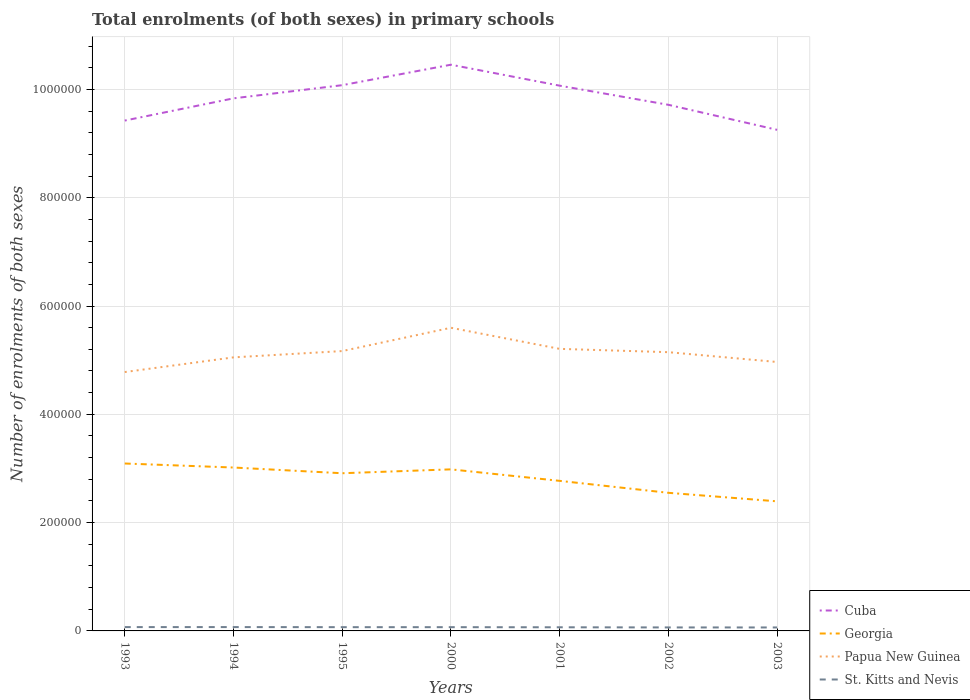How many different coloured lines are there?
Provide a short and direct response. 4. Is the number of lines equal to the number of legend labels?
Ensure brevity in your answer.  Yes. Across all years, what is the maximum number of enrolments in primary schools in Georgia?
Keep it short and to the point. 2.39e+05. What is the total number of enrolments in primary schools in St. Kitts and Nevis in the graph?
Give a very brief answer. 691. What is the difference between the highest and the second highest number of enrolments in primary schools in Papua New Guinea?
Provide a short and direct response. 8.18e+04. What is the difference between the highest and the lowest number of enrolments in primary schools in Papua New Guinea?
Make the answer very short. 4. Is the number of enrolments in primary schools in Papua New Guinea strictly greater than the number of enrolments in primary schools in Cuba over the years?
Offer a terse response. Yes. Are the values on the major ticks of Y-axis written in scientific E-notation?
Your answer should be very brief. No. Does the graph contain any zero values?
Make the answer very short. No. Does the graph contain grids?
Provide a short and direct response. Yes. Where does the legend appear in the graph?
Provide a short and direct response. Bottom right. How many legend labels are there?
Keep it short and to the point. 4. What is the title of the graph?
Provide a succinct answer. Total enrolments (of both sexes) in primary schools. Does "Solomon Islands" appear as one of the legend labels in the graph?
Ensure brevity in your answer.  No. What is the label or title of the X-axis?
Keep it short and to the point. Years. What is the label or title of the Y-axis?
Ensure brevity in your answer.  Number of enrolments of both sexes. What is the Number of enrolments of both sexes of Cuba in 1993?
Your response must be concise. 9.42e+05. What is the Number of enrolments of both sexes of Georgia in 1993?
Make the answer very short. 3.09e+05. What is the Number of enrolments of both sexes of Papua New Guinea in 1993?
Make the answer very short. 4.78e+05. What is the Number of enrolments of both sexes of St. Kitts and Nevis in 1993?
Keep it short and to the point. 7068. What is the Number of enrolments of both sexes in Cuba in 1994?
Provide a succinct answer. 9.83e+05. What is the Number of enrolments of both sexes of Georgia in 1994?
Provide a short and direct response. 3.02e+05. What is the Number of enrolments of both sexes in Papua New Guinea in 1994?
Your response must be concise. 5.05e+05. What is the Number of enrolments of both sexes in St. Kitts and Nevis in 1994?
Ensure brevity in your answer.  7092. What is the Number of enrolments of both sexes of Cuba in 1995?
Provide a short and direct response. 1.01e+06. What is the Number of enrolments of both sexes in Georgia in 1995?
Provide a succinct answer. 2.91e+05. What is the Number of enrolments of both sexes of Papua New Guinea in 1995?
Offer a very short reply. 5.17e+05. What is the Number of enrolments of both sexes in St. Kitts and Nevis in 1995?
Make the answer very short. 6938. What is the Number of enrolments of both sexes in Cuba in 2000?
Offer a terse response. 1.05e+06. What is the Number of enrolments of both sexes of Georgia in 2000?
Your answer should be very brief. 2.98e+05. What is the Number of enrolments of both sexes in Papua New Guinea in 2000?
Keep it short and to the point. 5.60e+05. What is the Number of enrolments of both sexes in St. Kitts and Nevis in 2000?
Offer a very short reply. 6922. What is the Number of enrolments of both sexes of Cuba in 2001?
Your response must be concise. 1.01e+06. What is the Number of enrolments of both sexes in Georgia in 2001?
Make the answer very short. 2.77e+05. What is the Number of enrolments of both sexes in Papua New Guinea in 2001?
Your answer should be compact. 5.21e+05. What is the Number of enrolments of both sexes in St. Kitts and Nevis in 2001?
Your answer should be compact. 6717. What is the Number of enrolments of both sexes in Cuba in 2002?
Your answer should be compact. 9.72e+05. What is the Number of enrolments of both sexes of Georgia in 2002?
Your answer should be compact. 2.55e+05. What is the Number of enrolments of both sexes of Papua New Guinea in 2002?
Your answer should be compact. 5.15e+05. What is the Number of enrolments of both sexes of St. Kitts and Nevis in 2002?
Provide a succinct answer. 6440. What is the Number of enrolments of both sexes in Cuba in 2003?
Make the answer very short. 9.25e+05. What is the Number of enrolments of both sexes of Georgia in 2003?
Offer a very short reply. 2.39e+05. What is the Number of enrolments of both sexes of Papua New Guinea in 2003?
Make the answer very short. 4.97e+05. What is the Number of enrolments of both sexes in St. Kitts and Nevis in 2003?
Your answer should be very brief. 6401. Across all years, what is the maximum Number of enrolments of both sexes in Cuba?
Your answer should be compact. 1.05e+06. Across all years, what is the maximum Number of enrolments of both sexes of Georgia?
Offer a very short reply. 3.09e+05. Across all years, what is the maximum Number of enrolments of both sexes of Papua New Guinea?
Provide a short and direct response. 5.60e+05. Across all years, what is the maximum Number of enrolments of both sexes in St. Kitts and Nevis?
Offer a very short reply. 7092. Across all years, what is the minimum Number of enrolments of both sexes in Cuba?
Make the answer very short. 9.25e+05. Across all years, what is the minimum Number of enrolments of both sexes of Georgia?
Provide a short and direct response. 2.39e+05. Across all years, what is the minimum Number of enrolments of both sexes in Papua New Guinea?
Provide a short and direct response. 4.78e+05. Across all years, what is the minimum Number of enrolments of both sexes of St. Kitts and Nevis?
Give a very brief answer. 6401. What is the total Number of enrolments of both sexes of Cuba in the graph?
Your response must be concise. 6.88e+06. What is the total Number of enrolments of both sexes of Georgia in the graph?
Offer a very short reply. 1.97e+06. What is the total Number of enrolments of both sexes of Papua New Guinea in the graph?
Make the answer very short. 3.59e+06. What is the total Number of enrolments of both sexes of St. Kitts and Nevis in the graph?
Keep it short and to the point. 4.76e+04. What is the difference between the Number of enrolments of both sexes in Cuba in 1993 and that in 1994?
Offer a terse response. -4.10e+04. What is the difference between the Number of enrolments of both sexes in Georgia in 1993 and that in 1994?
Provide a short and direct response. 7421. What is the difference between the Number of enrolments of both sexes in Papua New Guinea in 1993 and that in 1994?
Ensure brevity in your answer.  -2.71e+04. What is the difference between the Number of enrolments of both sexes in St. Kitts and Nevis in 1993 and that in 1994?
Give a very brief answer. -24. What is the difference between the Number of enrolments of both sexes of Cuba in 1993 and that in 1995?
Give a very brief answer. -6.53e+04. What is the difference between the Number of enrolments of both sexes of Georgia in 1993 and that in 1995?
Provide a short and direct response. 1.80e+04. What is the difference between the Number of enrolments of both sexes in Papua New Guinea in 1993 and that in 1995?
Your response must be concise. -3.88e+04. What is the difference between the Number of enrolments of both sexes in St. Kitts and Nevis in 1993 and that in 1995?
Your answer should be very brief. 130. What is the difference between the Number of enrolments of both sexes of Cuba in 1993 and that in 2000?
Your answer should be compact. -1.03e+05. What is the difference between the Number of enrolments of both sexes in Georgia in 1993 and that in 2000?
Ensure brevity in your answer.  1.08e+04. What is the difference between the Number of enrolments of both sexes of Papua New Guinea in 1993 and that in 2000?
Keep it short and to the point. -8.18e+04. What is the difference between the Number of enrolments of both sexes in St. Kitts and Nevis in 1993 and that in 2000?
Your response must be concise. 146. What is the difference between the Number of enrolments of both sexes in Cuba in 1993 and that in 2001?
Your answer should be very brief. -6.45e+04. What is the difference between the Number of enrolments of both sexes of Georgia in 1993 and that in 2001?
Give a very brief answer. 3.20e+04. What is the difference between the Number of enrolments of both sexes in Papua New Guinea in 1993 and that in 2001?
Offer a terse response. -4.28e+04. What is the difference between the Number of enrolments of both sexes of St. Kitts and Nevis in 1993 and that in 2001?
Your answer should be compact. 351. What is the difference between the Number of enrolments of both sexes in Cuba in 1993 and that in 2002?
Your answer should be very brief. -2.91e+04. What is the difference between the Number of enrolments of both sexes of Georgia in 1993 and that in 2002?
Offer a very short reply. 5.41e+04. What is the difference between the Number of enrolments of both sexes in Papua New Guinea in 1993 and that in 2002?
Offer a terse response. -3.67e+04. What is the difference between the Number of enrolments of both sexes of St. Kitts and Nevis in 1993 and that in 2002?
Provide a short and direct response. 628. What is the difference between the Number of enrolments of both sexes of Cuba in 1993 and that in 2003?
Ensure brevity in your answer.  1.71e+04. What is the difference between the Number of enrolments of both sexes of Georgia in 1993 and that in 2003?
Your answer should be very brief. 6.99e+04. What is the difference between the Number of enrolments of both sexes in Papua New Guinea in 1993 and that in 2003?
Provide a short and direct response. -1.86e+04. What is the difference between the Number of enrolments of both sexes of St. Kitts and Nevis in 1993 and that in 2003?
Give a very brief answer. 667. What is the difference between the Number of enrolments of both sexes of Cuba in 1994 and that in 1995?
Provide a short and direct response. -2.43e+04. What is the difference between the Number of enrolments of both sexes in Georgia in 1994 and that in 1995?
Give a very brief answer. 1.06e+04. What is the difference between the Number of enrolments of both sexes of Papua New Guinea in 1994 and that in 1995?
Your response must be concise. -1.16e+04. What is the difference between the Number of enrolments of both sexes of St. Kitts and Nevis in 1994 and that in 1995?
Ensure brevity in your answer.  154. What is the difference between the Number of enrolments of both sexes in Cuba in 1994 and that in 2000?
Keep it short and to the point. -6.21e+04. What is the difference between the Number of enrolments of both sexes in Georgia in 1994 and that in 2000?
Your response must be concise. 3380. What is the difference between the Number of enrolments of both sexes in Papua New Guinea in 1994 and that in 2000?
Keep it short and to the point. -5.47e+04. What is the difference between the Number of enrolments of both sexes of St. Kitts and Nevis in 1994 and that in 2000?
Your answer should be very brief. 170. What is the difference between the Number of enrolments of both sexes of Cuba in 1994 and that in 2001?
Offer a very short reply. -2.34e+04. What is the difference between the Number of enrolments of both sexes of Georgia in 1994 and that in 2001?
Offer a terse response. 2.46e+04. What is the difference between the Number of enrolments of both sexes of Papua New Guinea in 1994 and that in 2001?
Your answer should be compact. -1.57e+04. What is the difference between the Number of enrolments of both sexes of St. Kitts and Nevis in 1994 and that in 2001?
Your answer should be very brief. 375. What is the difference between the Number of enrolments of both sexes in Cuba in 1994 and that in 2002?
Your answer should be compact. 1.19e+04. What is the difference between the Number of enrolments of both sexes in Georgia in 1994 and that in 2002?
Keep it short and to the point. 4.67e+04. What is the difference between the Number of enrolments of both sexes in Papua New Guinea in 1994 and that in 2002?
Provide a succinct answer. -9582. What is the difference between the Number of enrolments of both sexes in St. Kitts and Nevis in 1994 and that in 2002?
Ensure brevity in your answer.  652. What is the difference between the Number of enrolments of both sexes in Cuba in 1994 and that in 2003?
Your answer should be compact. 5.81e+04. What is the difference between the Number of enrolments of both sexes in Georgia in 1994 and that in 2003?
Offer a very short reply. 6.24e+04. What is the difference between the Number of enrolments of both sexes of Papua New Guinea in 1994 and that in 2003?
Provide a short and direct response. 8537. What is the difference between the Number of enrolments of both sexes in St. Kitts and Nevis in 1994 and that in 2003?
Offer a terse response. 691. What is the difference between the Number of enrolments of both sexes in Cuba in 1995 and that in 2000?
Provide a succinct answer. -3.78e+04. What is the difference between the Number of enrolments of both sexes in Georgia in 1995 and that in 2000?
Offer a terse response. -7177. What is the difference between the Number of enrolments of both sexes of Papua New Guinea in 1995 and that in 2000?
Your answer should be compact. -4.30e+04. What is the difference between the Number of enrolments of both sexes in St. Kitts and Nevis in 1995 and that in 2000?
Make the answer very short. 16. What is the difference between the Number of enrolments of both sexes of Cuba in 1995 and that in 2001?
Your response must be concise. 881. What is the difference between the Number of enrolments of both sexes in Georgia in 1995 and that in 2001?
Make the answer very short. 1.41e+04. What is the difference between the Number of enrolments of both sexes in Papua New Guinea in 1995 and that in 2001?
Provide a short and direct response. -4049. What is the difference between the Number of enrolments of both sexes in St. Kitts and Nevis in 1995 and that in 2001?
Offer a terse response. 221. What is the difference between the Number of enrolments of both sexes of Cuba in 1995 and that in 2002?
Your response must be concise. 3.62e+04. What is the difference between the Number of enrolments of both sexes in Georgia in 1995 and that in 2002?
Make the answer very short. 3.61e+04. What is the difference between the Number of enrolments of both sexes in Papua New Guinea in 1995 and that in 2002?
Provide a short and direct response. 2062. What is the difference between the Number of enrolments of both sexes in St. Kitts and Nevis in 1995 and that in 2002?
Keep it short and to the point. 498. What is the difference between the Number of enrolments of both sexes in Cuba in 1995 and that in 2003?
Give a very brief answer. 8.24e+04. What is the difference between the Number of enrolments of both sexes of Georgia in 1995 and that in 2003?
Offer a terse response. 5.19e+04. What is the difference between the Number of enrolments of both sexes in Papua New Guinea in 1995 and that in 2003?
Make the answer very short. 2.02e+04. What is the difference between the Number of enrolments of both sexes in St. Kitts and Nevis in 1995 and that in 2003?
Offer a terse response. 537. What is the difference between the Number of enrolments of both sexes of Cuba in 2000 and that in 2001?
Ensure brevity in your answer.  3.87e+04. What is the difference between the Number of enrolments of both sexes of Georgia in 2000 and that in 2001?
Provide a succinct answer. 2.12e+04. What is the difference between the Number of enrolments of both sexes in Papua New Guinea in 2000 and that in 2001?
Your answer should be very brief. 3.90e+04. What is the difference between the Number of enrolments of both sexes of St. Kitts and Nevis in 2000 and that in 2001?
Your answer should be compact. 205. What is the difference between the Number of enrolments of both sexes in Cuba in 2000 and that in 2002?
Ensure brevity in your answer.  7.40e+04. What is the difference between the Number of enrolments of both sexes in Georgia in 2000 and that in 2002?
Keep it short and to the point. 4.33e+04. What is the difference between the Number of enrolments of both sexes in Papua New Guinea in 2000 and that in 2002?
Provide a short and direct response. 4.51e+04. What is the difference between the Number of enrolments of both sexes in St. Kitts and Nevis in 2000 and that in 2002?
Make the answer very short. 482. What is the difference between the Number of enrolments of both sexes in Cuba in 2000 and that in 2003?
Your answer should be compact. 1.20e+05. What is the difference between the Number of enrolments of both sexes in Georgia in 2000 and that in 2003?
Your response must be concise. 5.91e+04. What is the difference between the Number of enrolments of both sexes of Papua New Guinea in 2000 and that in 2003?
Make the answer very short. 6.32e+04. What is the difference between the Number of enrolments of both sexes of St. Kitts and Nevis in 2000 and that in 2003?
Your response must be concise. 521. What is the difference between the Number of enrolments of both sexes of Cuba in 2001 and that in 2002?
Offer a very short reply. 3.53e+04. What is the difference between the Number of enrolments of both sexes in Georgia in 2001 and that in 2002?
Offer a very short reply. 2.21e+04. What is the difference between the Number of enrolments of both sexes of Papua New Guinea in 2001 and that in 2002?
Your answer should be very brief. 6111. What is the difference between the Number of enrolments of both sexes of St. Kitts and Nevis in 2001 and that in 2002?
Provide a succinct answer. 277. What is the difference between the Number of enrolments of both sexes in Cuba in 2001 and that in 2003?
Provide a short and direct response. 8.16e+04. What is the difference between the Number of enrolments of both sexes of Georgia in 2001 and that in 2003?
Your answer should be compact. 3.78e+04. What is the difference between the Number of enrolments of both sexes in Papua New Guinea in 2001 and that in 2003?
Ensure brevity in your answer.  2.42e+04. What is the difference between the Number of enrolments of both sexes of St. Kitts and Nevis in 2001 and that in 2003?
Your response must be concise. 316. What is the difference between the Number of enrolments of both sexes in Cuba in 2002 and that in 2003?
Make the answer very short. 4.62e+04. What is the difference between the Number of enrolments of both sexes of Georgia in 2002 and that in 2003?
Keep it short and to the point. 1.57e+04. What is the difference between the Number of enrolments of both sexes in Papua New Guinea in 2002 and that in 2003?
Give a very brief answer. 1.81e+04. What is the difference between the Number of enrolments of both sexes of St. Kitts and Nevis in 2002 and that in 2003?
Provide a short and direct response. 39. What is the difference between the Number of enrolments of both sexes of Cuba in 1993 and the Number of enrolments of both sexes of Georgia in 1994?
Ensure brevity in your answer.  6.41e+05. What is the difference between the Number of enrolments of both sexes of Cuba in 1993 and the Number of enrolments of both sexes of Papua New Guinea in 1994?
Provide a short and direct response. 4.37e+05. What is the difference between the Number of enrolments of both sexes in Cuba in 1993 and the Number of enrolments of both sexes in St. Kitts and Nevis in 1994?
Provide a succinct answer. 9.35e+05. What is the difference between the Number of enrolments of both sexes in Georgia in 1993 and the Number of enrolments of both sexes in Papua New Guinea in 1994?
Your answer should be very brief. -1.96e+05. What is the difference between the Number of enrolments of both sexes in Georgia in 1993 and the Number of enrolments of both sexes in St. Kitts and Nevis in 1994?
Offer a very short reply. 3.02e+05. What is the difference between the Number of enrolments of both sexes of Papua New Guinea in 1993 and the Number of enrolments of both sexes of St. Kitts and Nevis in 1994?
Offer a very short reply. 4.71e+05. What is the difference between the Number of enrolments of both sexes in Cuba in 1993 and the Number of enrolments of both sexes in Georgia in 1995?
Make the answer very short. 6.51e+05. What is the difference between the Number of enrolments of both sexes of Cuba in 1993 and the Number of enrolments of both sexes of Papua New Guinea in 1995?
Your answer should be very brief. 4.26e+05. What is the difference between the Number of enrolments of both sexes in Cuba in 1993 and the Number of enrolments of both sexes in St. Kitts and Nevis in 1995?
Provide a succinct answer. 9.35e+05. What is the difference between the Number of enrolments of both sexes of Georgia in 1993 and the Number of enrolments of both sexes of Papua New Guinea in 1995?
Ensure brevity in your answer.  -2.08e+05. What is the difference between the Number of enrolments of both sexes in Georgia in 1993 and the Number of enrolments of both sexes in St. Kitts and Nevis in 1995?
Offer a terse response. 3.02e+05. What is the difference between the Number of enrolments of both sexes in Papua New Guinea in 1993 and the Number of enrolments of both sexes in St. Kitts and Nevis in 1995?
Your answer should be compact. 4.71e+05. What is the difference between the Number of enrolments of both sexes of Cuba in 1993 and the Number of enrolments of both sexes of Georgia in 2000?
Ensure brevity in your answer.  6.44e+05. What is the difference between the Number of enrolments of both sexes of Cuba in 1993 and the Number of enrolments of both sexes of Papua New Guinea in 2000?
Provide a short and direct response. 3.83e+05. What is the difference between the Number of enrolments of both sexes of Cuba in 1993 and the Number of enrolments of both sexes of St. Kitts and Nevis in 2000?
Offer a very short reply. 9.36e+05. What is the difference between the Number of enrolments of both sexes of Georgia in 1993 and the Number of enrolments of both sexes of Papua New Guinea in 2000?
Offer a terse response. -2.51e+05. What is the difference between the Number of enrolments of both sexes of Georgia in 1993 and the Number of enrolments of both sexes of St. Kitts and Nevis in 2000?
Your answer should be very brief. 3.02e+05. What is the difference between the Number of enrolments of both sexes of Papua New Guinea in 1993 and the Number of enrolments of both sexes of St. Kitts and Nevis in 2000?
Your answer should be compact. 4.71e+05. What is the difference between the Number of enrolments of both sexes of Cuba in 1993 and the Number of enrolments of both sexes of Georgia in 2001?
Keep it short and to the point. 6.65e+05. What is the difference between the Number of enrolments of both sexes of Cuba in 1993 and the Number of enrolments of both sexes of Papua New Guinea in 2001?
Your answer should be very brief. 4.22e+05. What is the difference between the Number of enrolments of both sexes of Cuba in 1993 and the Number of enrolments of both sexes of St. Kitts and Nevis in 2001?
Make the answer very short. 9.36e+05. What is the difference between the Number of enrolments of both sexes in Georgia in 1993 and the Number of enrolments of both sexes in Papua New Guinea in 2001?
Give a very brief answer. -2.12e+05. What is the difference between the Number of enrolments of both sexes of Georgia in 1993 and the Number of enrolments of both sexes of St. Kitts and Nevis in 2001?
Give a very brief answer. 3.02e+05. What is the difference between the Number of enrolments of both sexes in Papua New Guinea in 1993 and the Number of enrolments of both sexes in St. Kitts and Nevis in 2001?
Provide a succinct answer. 4.71e+05. What is the difference between the Number of enrolments of both sexes of Cuba in 1993 and the Number of enrolments of both sexes of Georgia in 2002?
Offer a very short reply. 6.87e+05. What is the difference between the Number of enrolments of both sexes of Cuba in 1993 and the Number of enrolments of both sexes of Papua New Guinea in 2002?
Your answer should be very brief. 4.28e+05. What is the difference between the Number of enrolments of both sexes in Cuba in 1993 and the Number of enrolments of both sexes in St. Kitts and Nevis in 2002?
Keep it short and to the point. 9.36e+05. What is the difference between the Number of enrolments of both sexes in Georgia in 1993 and the Number of enrolments of both sexes in Papua New Guinea in 2002?
Provide a succinct answer. -2.06e+05. What is the difference between the Number of enrolments of both sexes of Georgia in 1993 and the Number of enrolments of both sexes of St. Kitts and Nevis in 2002?
Your answer should be very brief. 3.03e+05. What is the difference between the Number of enrolments of both sexes of Papua New Guinea in 1993 and the Number of enrolments of both sexes of St. Kitts and Nevis in 2002?
Provide a succinct answer. 4.72e+05. What is the difference between the Number of enrolments of both sexes of Cuba in 1993 and the Number of enrolments of both sexes of Georgia in 2003?
Keep it short and to the point. 7.03e+05. What is the difference between the Number of enrolments of both sexes of Cuba in 1993 and the Number of enrolments of both sexes of Papua New Guinea in 2003?
Keep it short and to the point. 4.46e+05. What is the difference between the Number of enrolments of both sexes in Cuba in 1993 and the Number of enrolments of both sexes in St. Kitts and Nevis in 2003?
Keep it short and to the point. 9.36e+05. What is the difference between the Number of enrolments of both sexes in Georgia in 1993 and the Number of enrolments of both sexes in Papua New Guinea in 2003?
Provide a short and direct response. -1.87e+05. What is the difference between the Number of enrolments of both sexes of Georgia in 1993 and the Number of enrolments of both sexes of St. Kitts and Nevis in 2003?
Give a very brief answer. 3.03e+05. What is the difference between the Number of enrolments of both sexes in Papua New Guinea in 1993 and the Number of enrolments of both sexes in St. Kitts and Nevis in 2003?
Your answer should be very brief. 4.72e+05. What is the difference between the Number of enrolments of both sexes of Cuba in 1994 and the Number of enrolments of both sexes of Georgia in 1995?
Your answer should be very brief. 6.92e+05. What is the difference between the Number of enrolments of both sexes in Cuba in 1994 and the Number of enrolments of both sexes in Papua New Guinea in 1995?
Give a very brief answer. 4.67e+05. What is the difference between the Number of enrolments of both sexes in Cuba in 1994 and the Number of enrolments of both sexes in St. Kitts and Nevis in 1995?
Give a very brief answer. 9.77e+05. What is the difference between the Number of enrolments of both sexes of Georgia in 1994 and the Number of enrolments of both sexes of Papua New Guinea in 1995?
Give a very brief answer. -2.15e+05. What is the difference between the Number of enrolments of both sexes of Georgia in 1994 and the Number of enrolments of both sexes of St. Kitts and Nevis in 1995?
Provide a succinct answer. 2.95e+05. What is the difference between the Number of enrolments of both sexes of Papua New Guinea in 1994 and the Number of enrolments of both sexes of St. Kitts and Nevis in 1995?
Give a very brief answer. 4.98e+05. What is the difference between the Number of enrolments of both sexes of Cuba in 1994 and the Number of enrolments of both sexes of Georgia in 2000?
Offer a very short reply. 6.85e+05. What is the difference between the Number of enrolments of both sexes of Cuba in 1994 and the Number of enrolments of both sexes of Papua New Guinea in 2000?
Your response must be concise. 4.24e+05. What is the difference between the Number of enrolments of both sexes in Cuba in 1994 and the Number of enrolments of both sexes in St. Kitts and Nevis in 2000?
Provide a short and direct response. 9.77e+05. What is the difference between the Number of enrolments of both sexes in Georgia in 1994 and the Number of enrolments of both sexes in Papua New Guinea in 2000?
Ensure brevity in your answer.  -2.58e+05. What is the difference between the Number of enrolments of both sexes in Georgia in 1994 and the Number of enrolments of both sexes in St. Kitts and Nevis in 2000?
Provide a succinct answer. 2.95e+05. What is the difference between the Number of enrolments of both sexes of Papua New Guinea in 1994 and the Number of enrolments of both sexes of St. Kitts and Nevis in 2000?
Offer a very short reply. 4.98e+05. What is the difference between the Number of enrolments of both sexes of Cuba in 1994 and the Number of enrolments of both sexes of Georgia in 2001?
Provide a short and direct response. 7.06e+05. What is the difference between the Number of enrolments of both sexes in Cuba in 1994 and the Number of enrolments of both sexes in Papua New Guinea in 2001?
Make the answer very short. 4.63e+05. What is the difference between the Number of enrolments of both sexes of Cuba in 1994 and the Number of enrolments of both sexes of St. Kitts and Nevis in 2001?
Your response must be concise. 9.77e+05. What is the difference between the Number of enrolments of both sexes of Georgia in 1994 and the Number of enrolments of both sexes of Papua New Guinea in 2001?
Your response must be concise. -2.19e+05. What is the difference between the Number of enrolments of both sexes in Georgia in 1994 and the Number of enrolments of both sexes in St. Kitts and Nevis in 2001?
Provide a succinct answer. 2.95e+05. What is the difference between the Number of enrolments of both sexes in Papua New Guinea in 1994 and the Number of enrolments of both sexes in St. Kitts and Nevis in 2001?
Provide a short and direct response. 4.98e+05. What is the difference between the Number of enrolments of both sexes in Cuba in 1994 and the Number of enrolments of both sexes in Georgia in 2002?
Offer a terse response. 7.28e+05. What is the difference between the Number of enrolments of both sexes of Cuba in 1994 and the Number of enrolments of both sexes of Papua New Guinea in 2002?
Provide a short and direct response. 4.69e+05. What is the difference between the Number of enrolments of both sexes in Cuba in 1994 and the Number of enrolments of both sexes in St. Kitts and Nevis in 2002?
Your answer should be compact. 9.77e+05. What is the difference between the Number of enrolments of both sexes of Georgia in 1994 and the Number of enrolments of both sexes of Papua New Guinea in 2002?
Provide a short and direct response. -2.13e+05. What is the difference between the Number of enrolments of both sexes of Georgia in 1994 and the Number of enrolments of both sexes of St. Kitts and Nevis in 2002?
Give a very brief answer. 2.95e+05. What is the difference between the Number of enrolments of both sexes of Papua New Guinea in 1994 and the Number of enrolments of both sexes of St. Kitts and Nevis in 2002?
Provide a succinct answer. 4.99e+05. What is the difference between the Number of enrolments of both sexes of Cuba in 1994 and the Number of enrolments of both sexes of Georgia in 2003?
Provide a short and direct response. 7.44e+05. What is the difference between the Number of enrolments of both sexes of Cuba in 1994 and the Number of enrolments of both sexes of Papua New Guinea in 2003?
Make the answer very short. 4.87e+05. What is the difference between the Number of enrolments of both sexes of Cuba in 1994 and the Number of enrolments of both sexes of St. Kitts and Nevis in 2003?
Offer a very short reply. 9.77e+05. What is the difference between the Number of enrolments of both sexes of Georgia in 1994 and the Number of enrolments of both sexes of Papua New Guinea in 2003?
Your answer should be compact. -1.95e+05. What is the difference between the Number of enrolments of both sexes in Georgia in 1994 and the Number of enrolments of both sexes in St. Kitts and Nevis in 2003?
Your answer should be very brief. 2.95e+05. What is the difference between the Number of enrolments of both sexes in Papua New Guinea in 1994 and the Number of enrolments of both sexes in St. Kitts and Nevis in 2003?
Provide a succinct answer. 4.99e+05. What is the difference between the Number of enrolments of both sexes of Cuba in 1995 and the Number of enrolments of both sexes of Georgia in 2000?
Provide a short and direct response. 7.09e+05. What is the difference between the Number of enrolments of both sexes in Cuba in 1995 and the Number of enrolments of both sexes in Papua New Guinea in 2000?
Your response must be concise. 4.48e+05. What is the difference between the Number of enrolments of both sexes in Cuba in 1995 and the Number of enrolments of both sexes in St. Kitts and Nevis in 2000?
Give a very brief answer. 1.00e+06. What is the difference between the Number of enrolments of both sexes of Georgia in 1995 and the Number of enrolments of both sexes of Papua New Guinea in 2000?
Provide a succinct answer. -2.69e+05. What is the difference between the Number of enrolments of both sexes in Georgia in 1995 and the Number of enrolments of both sexes in St. Kitts and Nevis in 2000?
Provide a short and direct response. 2.84e+05. What is the difference between the Number of enrolments of both sexes in Papua New Guinea in 1995 and the Number of enrolments of both sexes in St. Kitts and Nevis in 2000?
Provide a succinct answer. 5.10e+05. What is the difference between the Number of enrolments of both sexes of Cuba in 1995 and the Number of enrolments of both sexes of Georgia in 2001?
Your response must be concise. 7.31e+05. What is the difference between the Number of enrolments of both sexes of Cuba in 1995 and the Number of enrolments of both sexes of Papua New Guinea in 2001?
Offer a terse response. 4.87e+05. What is the difference between the Number of enrolments of both sexes of Cuba in 1995 and the Number of enrolments of both sexes of St. Kitts and Nevis in 2001?
Make the answer very short. 1.00e+06. What is the difference between the Number of enrolments of both sexes of Georgia in 1995 and the Number of enrolments of both sexes of Papua New Guinea in 2001?
Your answer should be compact. -2.30e+05. What is the difference between the Number of enrolments of both sexes in Georgia in 1995 and the Number of enrolments of both sexes in St. Kitts and Nevis in 2001?
Offer a very short reply. 2.84e+05. What is the difference between the Number of enrolments of both sexes of Papua New Guinea in 1995 and the Number of enrolments of both sexes of St. Kitts and Nevis in 2001?
Make the answer very short. 5.10e+05. What is the difference between the Number of enrolments of both sexes in Cuba in 1995 and the Number of enrolments of both sexes in Georgia in 2002?
Provide a succinct answer. 7.53e+05. What is the difference between the Number of enrolments of both sexes in Cuba in 1995 and the Number of enrolments of both sexes in Papua New Guinea in 2002?
Provide a short and direct response. 4.93e+05. What is the difference between the Number of enrolments of both sexes in Cuba in 1995 and the Number of enrolments of both sexes in St. Kitts and Nevis in 2002?
Make the answer very short. 1.00e+06. What is the difference between the Number of enrolments of both sexes in Georgia in 1995 and the Number of enrolments of both sexes in Papua New Guinea in 2002?
Your response must be concise. -2.24e+05. What is the difference between the Number of enrolments of both sexes of Georgia in 1995 and the Number of enrolments of both sexes of St. Kitts and Nevis in 2002?
Provide a short and direct response. 2.85e+05. What is the difference between the Number of enrolments of both sexes in Papua New Guinea in 1995 and the Number of enrolments of both sexes in St. Kitts and Nevis in 2002?
Offer a terse response. 5.10e+05. What is the difference between the Number of enrolments of both sexes in Cuba in 1995 and the Number of enrolments of both sexes in Georgia in 2003?
Keep it short and to the point. 7.68e+05. What is the difference between the Number of enrolments of both sexes in Cuba in 1995 and the Number of enrolments of both sexes in Papua New Guinea in 2003?
Give a very brief answer. 5.11e+05. What is the difference between the Number of enrolments of both sexes of Cuba in 1995 and the Number of enrolments of both sexes of St. Kitts and Nevis in 2003?
Your answer should be compact. 1.00e+06. What is the difference between the Number of enrolments of both sexes in Georgia in 1995 and the Number of enrolments of both sexes in Papua New Guinea in 2003?
Your answer should be compact. -2.05e+05. What is the difference between the Number of enrolments of both sexes in Georgia in 1995 and the Number of enrolments of both sexes in St. Kitts and Nevis in 2003?
Offer a terse response. 2.85e+05. What is the difference between the Number of enrolments of both sexes of Papua New Guinea in 1995 and the Number of enrolments of both sexes of St. Kitts and Nevis in 2003?
Give a very brief answer. 5.10e+05. What is the difference between the Number of enrolments of both sexes of Cuba in 2000 and the Number of enrolments of both sexes of Georgia in 2001?
Your answer should be compact. 7.68e+05. What is the difference between the Number of enrolments of both sexes of Cuba in 2000 and the Number of enrolments of both sexes of Papua New Guinea in 2001?
Your answer should be compact. 5.25e+05. What is the difference between the Number of enrolments of both sexes in Cuba in 2000 and the Number of enrolments of both sexes in St. Kitts and Nevis in 2001?
Offer a very short reply. 1.04e+06. What is the difference between the Number of enrolments of both sexes in Georgia in 2000 and the Number of enrolments of both sexes in Papua New Guinea in 2001?
Offer a very short reply. -2.22e+05. What is the difference between the Number of enrolments of both sexes of Georgia in 2000 and the Number of enrolments of both sexes of St. Kitts and Nevis in 2001?
Your answer should be very brief. 2.92e+05. What is the difference between the Number of enrolments of both sexes of Papua New Guinea in 2000 and the Number of enrolments of both sexes of St. Kitts and Nevis in 2001?
Provide a succinct answer. 5.53e+05. What is the difference between the Number of enrolments of both sexes in Cuba in 2000 and the Number of enrolments of both sexes in Georgia in 2002?
Provide a short and direct response. 7.91e+05. What is the difference between the Number of enrolments of both sexes in Cuba in 2000 and the Number of enrolments of both sexes in Papua New Guinea in 2002?
Make the answer very short. 5.31e+05. What is the difference between the Number of enrolments of both sexes in Cuba in 2000 and the Number of enrolments of both sexes in St. Kitts and Nevis in 2002?
Provide a short and direct response. 1.04e+06. What is the difference between the Number of enrolments of both sexes of Georgia in 2000 and the Number of enrolments of both sexes of Papua New Guinea in 2002?
Your answer should be compact. -2.16e+05. What is the difference between the Number of enrolments of both sexes of Georgia in 2000 and the Number of enrolments of both sexes of St. Kitts and Nevis in 2002?
Keep it short and to the point. 2.92e+05. What is the difference between the Number of enrolments of both sexes of Papua New Guinea in 2000 and the Number of enrolments of both sexes of St. Kitts and Nevis in 2002?
Keep it short and to the point. 5.53e+05. What is the difference between the Number of enrolments of both sexes in Cuba in 2000 and the Number of enrolments of both sexes in Georgia in 2003?
Provide a succinct answer. 8.06e+05. What is the difference between the Number of enrolments of both sexes in Cuba in 2000 and the Number of enrolments of both sexes in Papua New Guinea in 2003?
Make the answer very short. 5.49e+05. What is the difference between the Number of enrolments of both sexes in Cuba in 2000 and the Number of enrolments of both sexes in St. Kitts and Nevis in 2003?
Provide a short and direct response. 1.04e+06. What is the difference between the Number of enrolments of both sexes of Georgia in 2000 and the Number of enrolments of both sexes of Papua New Guinea in 2003?
Give a very brief answer. -1.98e+05. What is the difference between the Number of enrolments of both sexes of Georgia in 2000 and the Number of enrolments of both sexes of St. Kitts and Nevis in 2003?
Provide a short and direct response. 2.92e+05. What is the difference between the Number of enrolments of both sexes in Papua New Guinea in 2000 and the Number of enrolments of both sexes in St. Kitts and Nevis in 2003?
Your response must be concise. 5.53e+05. What is the difference between the Number of enrolments of both sexes in Cuba in 2001 and the Number of enrolments of both sexes in Georgia in 2002?
Make the answer very short. 7.52e+05. What is the difference between the Number of enrolments of both sexes of Cuba in 2001 and the Number of enrolments of both sexes of Papua New Guinea in 2002?
Provide a short and direct response. 4.92e+05. What is the difference between the Number of enrolments of both sexes of Cuba in 2001 and the Number of enrolments of both sexes of St. Kitts and Nevis in 2002?
Keep it short and to the point. 1.00e+06. What is the difference between the Number of enrolments of both sexes in Georgia in 2001 and the Number of enrolments of both sexes in Papua New Guinea in 2002?
Your response must be concise. -2.38e+05. What is the difference between the Number of enrolments of both sexes of Georgia in 2001 and the Number of enrolments of both sexes of St. Kitts and Nevis in 2002?
Provide a short and direct response. 2.71e+05. What is the difference between the Number of enrolments of both sexes in Papua New Guinea in 2001 and the Number of enrolments of both sexes in St. Kitts and Nevis in 2002?
Your answer should be very brief. 5.14e+05. What is the difference between the Number of enrolments of both sexes of Cuba in 2001 and the Number of enrolments of both sexes of Georgia in 2003?
Provide a succinct answer. 7.68e+05. What is the difference between the Number of enrolments of both sexes in Cuba in 2001 and the Number of enrolments of both sexes in Papua New Guinea in 2003?
Your answer should be compact. 5.10e+05. What is the difference between the Number of enrolments of both sexes in Cuba in 2001 and the Number of enrolments of both sexes in St. Kitts and Nevis in 2003?
Make the answer very short. 1.00e+06. What is the difference between the Number of enrolments of both sexes of Georgia in 2001 and the Number of enrolments of both sexes of Papua New Guinea in 2003?
Give a very brief answer. -2.19e+05. What is the difference between the Number of enrolments of both sexes of Georgia in 2001 and the Number of enrolments of both sexes of St. Kitts and Nevis in 2003?
Keep it short and to the point. 2.71e+05. What is the difference between the Number of enrolments of both sexes of Papua New Guinea in 2001 and the Number of enrolments of both sexes of St. Kitts and Nevis in 2003?
Your answer should be compact. 5.14e+05. What is the difference between the Number of enrolments of both sexes of Cuba in 2002 and the Number of enrolments of both sexes of Georgia in 2003?
Your response must be concise. 7.32e+05. What is the difference between the Number of enrolments of both sexes of Cuba in 2002 and the Number of enrolments of both sexes of Papua New Guinea in 2003?
Your response must be concise. 4.75e+05. What is the difference between the Number of enrolments of both sexes in Cuba in 2002 and the Number of enrolments of both sexes in St. Kitts and Nevis in 2003?
Make the answer very short. 9.65e+05. What is the difference between the Number of enrolments of both sexes in Georgia in 2002 and the Number of enrolments of both sexes in Papua New Guinea in 2003?
Your answer should be very brief. -2.42e+05. What is the difference between the Number of enrolments of both sexes of Georgia in 2002 and the Number of enrolments of both sexes of St. Kitts and Nevis in 2003?
Your response must be concise. 2.49e+05. What is the difference between the Number of enrolments of both sexes of Papua New Guinea in 2002 and the Number of enrolments of both sexes of St. Kitts and Nevis in 2003?
Give a very brief answer. 5.08e+05. What is the average Number of enrolments of both sexes in Cuba per year?
Your response must be concise. 9.83e+05. What is the average Number of enrolments of both sexes of Georgia per year?
Keep it short and to the point. 2.82e+05. What is the average Number of enrolments of both sexes of Papua New Guinea per year?
Offer a terse response. 5.13e+05. What is the average Number of enrolments of both sexes in St. Kitts and Nevis per year?
Offer a terse response. 6796.86. In the year 1993, what is the difference between the Number of enrolments of both sexes of Cuba and Number of enrolments of both sexes of Georgia?
Offer a terse response. 6.33e+05. In the year 1993, what is the difference between the Number of enrolments of both sexes in Cuba and Number of enrolments of both sexes in Papua New Guinea?
Give a very brief answer. 4.64e+05. In the year 1993, what is the difference between the Number of enrolments of both sexes in Cuba and Number of enrolments of both sexes in St. Kitts and Nevis?
Offer a very short reply. 9.35e+05. In the year 1993, what is the difference between the Number of enrolments of both sexes in Georgia and Number of enrolments of both sexes in Papua New Guinea?
Your response must be concise. -1.69e+05. In the year 1993, what is the difference between the Number of enrolments of both sexes of Georgia and Number of enrolments of both sexes of St. Kitts and Nevis?
Offer a terse response. 3.02e+05. In the year 1993, what is the difference between the Number of enrolments of both sexes of Papua New Guinea and Number of enrolments of both sexes of St. Kitts and Nevis?
Offer a terse response. 4.71e+05. In the year 1994, what is the difference between the Number of enrolments of both sexes of Cuba and Number of enrolments of both sexes of Georgia?
Offer a terse response. 6.82e+05. In the year 1994, what is the difference between the Number of enrolments of both sexes in Cuba and Number of enrolments of both sexes in Papua New Guinea?
Provide a short and direct response. 4.78e+05. In the year 1994, what is the difference between the Number of enrolments of both sexes in Cuba and Number of enrolments of both sexes in St. Kitts and Nevis?
Your response must be concise. 9.76e+05. In the year 1994, what is the difference between the Number of enrolments of both sexes in Georgia and Number of enrolments of both sexes in Papua New Guinea?
Offer a very short reply. -2.03e+05. In the year 1994, what is the difference between the Number of enrolments of both sexes of Georgia and Number of enrolments of both sexes of St. Kitts and Nevis?
Your response must be concise. 2.95e+05. In the year 1994, what is the difference between the Number of enrolments of both sexes of Papua New Guinea and Number of enrolments of both sexes of St. Kitts and Nevis?
Make the answer very short. 4.98e+05. In the year 1995, what is the difference between the Number of enrolments of both sexes of Cuba and Number of enrolments of both sexes of Georgia?
Give a very brief answer. 7.17e+05. In the year 1995, what is the difference between the Number of enrolments of both sexes of Cuba and Number of enrolments of both sexes of Papua New Guinea?
Keep it short and to the point. 4.91e+05. In the year 1995, what is the difference between the Number of enrolments of both sexes of Cuba and Number of enrolments of both sexes of St. Kitts and Nevis?
Offer a very short reply. 1.00e+06. In the year 1995, what is the difference between the Number of enrolments of both sexes of Georgia and Number of enrolments of both sexes of Papua New Guinea?
Offer a very short reply. -2.26e+05. In the year 1995, what is the difference between the Number of enrolments of both sexes of Georgia and Number of enrolments of both sexes of St. Kitts and Nevis?
Your response must be concise. 2.84e+05. In the year 1995, what is the difference between the Number of enrolments of both sexes in Papua New Guinea and Number of enrolments of both sexes in St. Kitts and Nevis?
Your answer should be very brief. 5.10e+05. In the year 2000, what is the difference between the Number of enrolments of both sexes of Cuba and Number of enrolments of both sexes of Georgia?
Ensure brevity in your answer.  7.47e+05. In the year 2000, what is the difference between the Number of enrolments of both sexes in Cuba and Number of enrolments of both sexes in Papua New Guinea?
Provide a short and direct response. 4.86e+05. In the year 2000, what is the difference between the Number of enrolments of both sexes of Cuba and Number of enrolments of both sexes of St. Kitts and Nevis?
Give a very brief answer. 1.04e+06. In the year 2000, what is the difference between the Number of enrolments of both sexes of Georgia and Number of enrolments of both sexes of Papua New Guinea?
Give a very brief answer. -2.61e+05. In the year 2000, what is the difference between the Number of enrolments of both sexes of Georgia and Number of enrolments of both sexes of St. Kitts and Nevis?
Give a very brief answer. 2.91e+05. In the year 2000, what is the difference between the Number of enrolments of both sexes in Papua New Guinea and Number of enrolments of both sexes in St. Kitts and Nevis?
Provide a short and direct response. 5.53e+05. In the year 2001, what is the difference between the Number of enrolments of both sexes of Cuba and Number of enrolments of both sexes of Georgia?
Your response must be concise. 7.30e+05. In the year 2001, what is the difference between the Number of enrolments of both sexes in Cuba and Number of enrolments of both sexes in Papua New Guinea?
Ensure brevity in your answer.  4.86e+05. In the year 2001, what is the difference between the Number of enrolments of both sexes of Cuba and Number of enrolments of both sexes of St. Kitts and Nevis?
Provide a short and direct response. 1.00e+06. In the year 2001, what is the difference between the Number of enrolments of both sexes in Georgia and Number of enrolments of both sexes in Papua New Guinea?
Your response must be concise. -2.44e+05. In the year 2001, what is the difference between the Number of enrolments of both sexes of Georgia and Number of enrolments of both sexes of St. Kitts and Nevis?
Provide a succinct answer. 2.70e+05. In the year 2001, what is the difference between the Number of enrolments of both sexes of Papua New Guinea and Number of enrolments of both sexes of St. Kitts and Nevis?
Provide a succinct answer. 5.14e+05. In the year 2002, what is the difference between the Number of enrolments of both sexes in Cuba and Number of enrolments of both sexes in Georgia?
Your response must be concise. 7.17e+05. In the year 2002, what is the difference between the Number of enrolments of both sexes of Cuba and Number of enrolments of both sexes of Papua New Guinea?
Your answer should be very brief. 4.57e+05. In the year 2002, what is the difference between the Number of enrolments of both sexes in Cuba and Number of enrolments of both sexes in St. Kitts and Nevis?
Offer a very short reply. 9.65e+05. In the year 2002, what is the difference between the Number of enrolments of both sexes in Georgia and Number of enrolments of both sexes in Papua New Guinea?
Keep it short and to the point. -2.60e+05. In the year 2002, what is the difference between the Number of enrolments of both sexes in Georgia and Number of enrolments of both sexes in St. Kitts and Nevis?
Your answer should be compact. 2.49e+05. In the year 2002, what is the difference between the Number of enrolments of both sexes of Papua New Guinea and Number of enrolments of both sexes of St. Kitts and Nevis?
Make the answer very short. 5.08e+05. In the year 2003, what is the difference between the Number of enrolments of both sexes in Cuba and Number of enrolments of both sexes in Georgia?
Give a very brief answer. 6.86e+05. In the year 2003, what is the difference between the Number of enrolments of both sexes of Cuba and Number of enrolments of both sexes of Papua New Guinea?
Offer a very short reply. 4.29e+05. In the year 2003, what is the difference between the Number of enrolments of both sexes in Cuba and Number of enrolments of both sexes in St. Kitts and Nevis?
Provide a short and direct response. 9.19e+05. In the year 2003, what is the difference between the Number of enrolments of both sexes in Georgia and Number of enrolments of both sexes in Papua New Guinea?
Provide a short and direct response. -2.57e+05. In the year 2003, what is the difference between the Number of enrolments of both sexes in Georgia and Number of enrolments of both sexes in St. Kitts and Nevis?
Give a very brief answer. 2.33e+05. In the year 2003, what is the difference between the Number of enrolments of both sexes in Papua New Guinea and Number of enrolments of both sexes in St. Kitts and Nevis?
Your answer should be very brief. 4.90e+05. What is the ratio of the Number of enrolments of both sexes in Cuba in 1993 to that in 1994?
Your response must be concise. 0.96. What is the ratio of the Number of enrolments of both sexes in Georgia in 1993 to that in 1994?
Offer a very short reply. 1.02. What is the ratio of the Number of enrolments of both sexes in Papua New Guinea in 1993 to that in 1994?
Make the answer very short. 0.95. What is the ratio of the Number of enrolments of both sexes in St. Kitts and Nevis in 1993 to that in 1994?
Give a very brief answer. 1. What is the ratio of the Number of enrolments of both sexes in Cuba in 1993 to that in 1995?
Your response must be concise. 0.94. What is the ratio of the Number of enrolments of both sexes in Georgia in 1993 to that in 1995?
Your answer should be compact. 1.06. What is the ratio of the Number of enrolments of both sexes in Papua New Guinea in 1993 to that in 1995?
Your answer should be compact. 0.93. What is the ratio of the Number of enrolments of both sexes in St. Kitts and Nevis in 1993 to that in 1995?
Keep it short and to the point. 1.02. What is the ratio of the Number of enrolments of both sexes in Cuba in 1993 to that in 2000?
Make the answer very short. 0.9. What is the ratio of the Number of enrolments of both sexes in Georgia in 1993 to that in 2000?
Give a very brief answer. 1.04. What is the ratio of the Number of enrolments of both sexes in Papua New Guinea in 1993 to that in 2000?
Offer a terse response. 0.85. What is the ratio of the Number of enrolments of both sexes of St. Kitts and Nevis in 1993 to that in 2000?
Your response must be concise. 1.02. What is the ratio of the Number of enrolments of both sexes of Cuba in 1993 to that in 2001?
Make the answer very short. 0.94. What is the ratio of the Number of enrolments of both sexes in Georgia in 1993 to that in 2001?
Offer a very short reply. 1.12. What is the ratio of the Number of enrolments of both sexes of Papua New Guinea in 1993 to that in 2001?
Keep it short and to the point. 0.92. What is the ratio of the Number of enrolments of both sexes of St. Kitts and Nevis in 1993 to that in 2001?
Provide a short and direct response. 1.05. What is the ratio of the Number of enrolments of both sexes in Georgia in 1993 to that in 2002?
Your answer should be compact. 1.21. What is the ratio of the Number of enrolments of both sexes in Papua New Guinea in 1993 to that in 2002?
Keep it short and to the point. 0.93. What is the ratio of the Number of enrolments of both sexes of St. Kitts and Nevis in 1993 to that in 2002?
Offer a terse response. 1.1. What is the ratio of the Number of enrolments of both sexes of Cuba in 1993 to that in 2003?
Your response must be concise. 1.02. What is the ratio of the Number of enrolments of both sexes in Georgia in 1993 to that in 2003?
Give a very brief answer. 1.29. What is the ratio of the Number of enrolments of both sexes of Papua New Guinea in 1993 to that in 2003?
Offer a terse response. 0.96. What is the ratio of the Number of enrolments of both sexes in St. Kitts and Nevis in 1993 to that in 2003?
Keep it short and to the point. 1.1. What is the ratio of the Number of enrolments of both sexes in Cuba in 1994 to that in 1995?
Your response must be concise. 0.98. What is the ratio of the Number of enrolments of both sexes in Georgia in 1994 to that in 1995?
Keep it short and to the point. 1.04. What is the ratio of the Number of enrolments of both sexes in Papua New Guinea in 1994 to that in 1995?
Provide a succinct answer. 0.98. What is the ratio of the Number of enrolments of both sexes in St. Kitts and Nevis in 1994 to that in 1995?
Offer a very short reply. 1.02. What is the ratio of the Number of enrolments of both sexes of Cuba in 1994 to that in 2000?
Give a very brief answer. 0.94. What is the ratio of the Number of enrolments of both sexes in Georgia in 1994 to that in 2000?
Provide a succinct answer. 1.01. What is the ratio of the Number of enrolments of both sexes in Papua New Guinea in 1994 to that in 2000?
Make the answer very short. 0.9. What is the ratio of the Number of enrolments of both sexes of St. Kitts and Nevis in 1994 to that in 2000?
Your response must be concise. 1.02. What is the ratio of the Number of enrolments of both sexes in Cuba in 1994 to that in 2001?
Offer a terse response. 0.98. What is the ratio of the Number of enrolments of both sexes of Georgia in 1994 to that in 2001?
Provide a succinct answer. 1.09. What is the ratio of the Number of enrolments of both sexes in Papua New Guinea in 1994 to that in 2001?
Keep it short and to the point. 0.97. What is the ratio of the Number of enrolments of both sexes in St. Kitts and Nevis in 1994 to that in 2001?
Offer a terse response. 1.06. What is the ratio of the Number of enrolments of both sexes in Cuba in 1994 to that in 2002?
Your answer should be compact. 1.01. What is the ratio of the Number of enrolments of both sexes of Georgia in 1994 to that in 2002?
Your answer should be very brief. 1.18. What is the ratio of the Number of enrolments of both sexes in Papua New Guinea in 1994 to that in 2002?
Keep it short and to the point. 0.98. What is the ratio of the Number of enrolments of both sexes of St. Kitts and Nevis in 1994 to that in 2002?
Provide a short and direct response. 1.1. What is the ratio of the Number of enrolments of both sexes of Cuba in 1994 to that in 2003?
Ensure brevity in your answer.  1.06. What is the ratio of the Number of enrolments of both sexes in Georgia in 1994 to that in 2003?
Provide a succinct answer. 1.26. What is the ratio of the Number of enrolments of both sexes of Papua New Guinea in 1994 to that in 2003?
Your answer should be very brief. 1.02. What is the ratio of the Number of enrolments of both sexes in St. Kitts and Nevis in 1994 to that in 2003?
Your response must be concise. 1.11. What is the ratio of the Number of enrolments of both sexes in Cuba in 1995 to that in 2000?
Keep it short and to the point. 0.96. What is the ratio of the Number of enrolments of both sexes of Georgia in 1995 to that in 2000?
Ensure brevity in your answer.  0.98. What is the ratio of the Number of enrolments of both sexes in Papua New Guinea in 1995 to that in 2000?
Ensure brevity in your answer.  0.92. What is the ratio of the Number of enrolments of both sexes in Georgia in 1995 to that in 2001?
Offer a very short reply. 1.05. What is the ratio of the Number of enrolments of both sexes in Papua New Guinea in 1995 to that in 2001?
Make the answer very short. 0.99. What is the ratio of the Number of enrolments of both sexes in St. Kitts and Nevis in 1995 to that in 2001?
Keep it short and to the point. 1.03. What is the ratio of the Number of enrolments of both sexes in Cuba in 1995 to that in 2002?
Provide a succinct answer. 1.04. What is the ratio of the Number of enrolments of both sexes of Georgia in 1995 to that in 2002?
Give a very brief answer. 1.14. What is the ratio of the Number of enrolments of both sexes in Papua New Guinea in 1995 to that in 2002?
Offer a terse response. 1. What is the ratio of the Number of enrolments of both sexes of St. Kitts and Nevis in 1995 to that in 2002?
Provide a short and direct response. 1.08. What is the ratio of the Number of enrolments of both sexes in Cuba in 1995 to that in 2003?
Your response must be concise. 1.09. What is the ratio of the Number of enrolments of both sexes in Georgia in 1995 to that in 2003?
Your answer should be very brief. 1.22. What is the ratio of the Number of enrolments of both sexes in Papua New Guinea in 1995 to that in 2003?
Your answer should be very brief. 1.04. What is the ratio of the Number of enrolments of both sexes of St. Kitts and Nevis in 1995 to that in 2003?
Provide a short and direct response. 1.08. What is the ratio of the Number of enrolments of both sexes in Cuba in 2000 to that in 2001?
Offer a terse response. 1.04. What is the ratio of the Number of enrolments of both sexes of Georgia in 2000 to that in 2001?
Keep it short and to the point. 1.08. What is the ratio of the Number of enrolments of both sexes in Papua New Guinea in 2000 to that in 2001?
Offer a very short reply. 1.07. What is the ratio of the Number of enrolments of both sexes in St. Kitts and Nevis in 2000 to that in 2001?
Your response must be concise. 1.03. What is the ratio of the Number of enrolments of both sexes of Cuba in 2000 to that in 2002?
Your answer should be very brief. 1.08. What is the ratio of the Number of enrolments of both sexes of Georgia in 2000 to that in 2002?
Offer a terse response. 1.17. What is the ratio of the Number of enrolments of both sexes in Papua New Guinea in 2000 to that in 2002?
Ensure brevity in your answer.  1.09. What is the ratio of the Number of enrolments of both sexes in St. Kitts and Nevis in 2000 to that in 2002?
Provide a succinct answer. 1.07. What is the ratio of the Number of enrolments of both sexes of Cuba in 2000 to that in 2003?
Your response must be concise. 1.13. What is the ratio of the Number of enrolments of both sexes in Georgia in 2000 to that in 2003?
Your response must be concise. 1.25. What is the ratio of the Number of enrolments of both sexes in Papua New Guinea in 2000 to that in 2003?
Your response must be concise. 1.13. What is the ratio of the Number of enrolments of both sexes in St. Kitts and Nevis in 2000 to that in 2003?
Ensure brevity in your answer.  1.08. What is the ratio of the Number of enrolments of both sexes in Cuba in 2001 to that in 2002?
Your answer should be very brief. 1.04. What is the ratio of the Number of enrolments of both sexes in Georgia in 2001 to that in 2002?
Provide a short and direct response. 1.09. What is the ratio of the Number of enrolments of both sexes of Papua New Guinea in 2001 to that in 2002?
Keep it short and to the point. 1.01. What is the ratio of the Number of enrolments of both sexes in St. Kitts and Nevis in 2001 to that in 2002?
Keep it short and to the point. 1.04. What is the ratio of the Number of enrolments of both sexes in Cuba in 2001 to that in 2003?
Your answer should be very brief. 1.09. What is the ratio of the Number of enrolments of both sexes of Georgia in 2001 to that in 2003?
Ensure brevity in your answer.  1.16. What is the ratio of the Number of enrolments of both sexes in Papua New Guinea in 2001 to that in 2003?
Offer a very short reply. 1.05. What is the ratio of the Number of enrolments of both sexes in St. Kitts and Nevis in 2001 to that in 2003?
Make the answer very short. 1.05. What is the ratio of the Number of enrolments of both sexes of Cuba in 2002 to that in 2003?
Keep it short and to the point. 1.05. What is the ratio of the Number of enrolments of both sexes of Georgia in 2002 to that in 2003?
Offer a very short reply. 1.07. What is the ratio of the Number of enrolments of both sexes in Papua New Guinea in 2002 to that in 2003?
Keep it short and to the point. 1.04. What is the difference between the highest and the second highest Number of enrolments of both sexes in Cuba?
Your answer should be very brief. 3.78e+04. What is the difference between the highest and the second highest Number of enrolments of both sexes of Georgia?
Provide a succinct answer. 7421. What is the difference between the highest and the second highest Number of enrolments of both sexes of Papua New Guinea?
Your answer should be compact. 3.90e+04. What is the difference between the highest and the lowest Number of enrolments of both sexes of Cuba?
Your answer should be very brief. 1.20e+05. What is the difference between the highest and the lowest Number of enrolments of both sexes in Georgia?
Provide a succinct answer. 6.99e+04. What is the difference between the highest and the lowest Number of enrolments of both sexes in Papua New Guinea?
Make the answer very short. 8.18e+04. What is the difference between the highest and the lowest Number of enrolments of both sexes of St. Kitts and Nevis?
Keep it short and to the point. 691. 